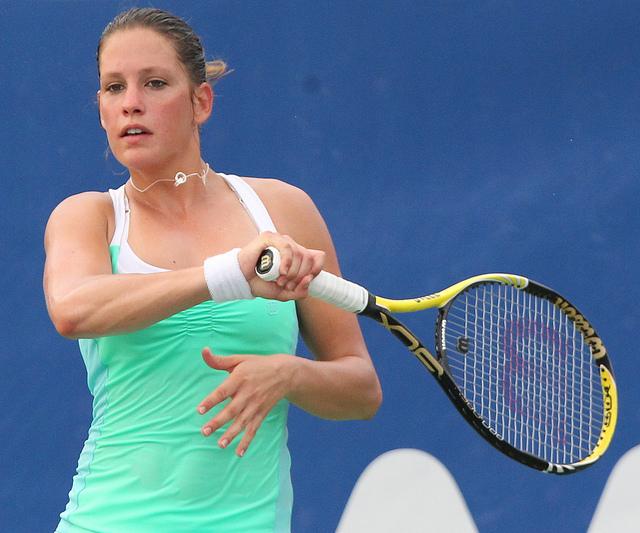What sport does this woman play?
Give a very brief answer. Tennis. What is she waiting?
Keep it brief. Not possible. What color is the dress?
Quick response, please. Green. What is on her right arm?
Short answer required. Wristband. 